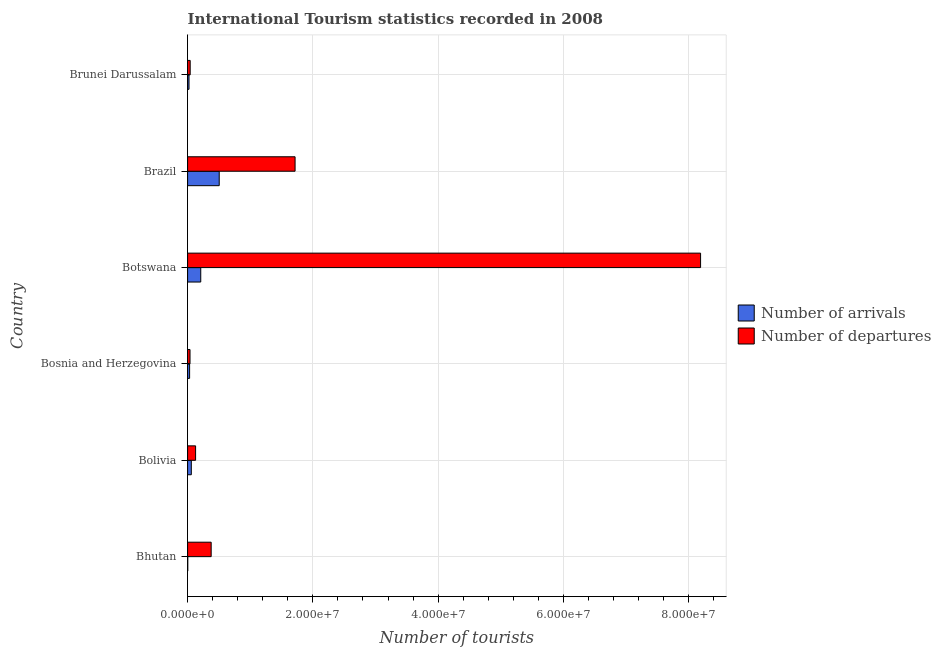How many different coloured bars are there?
Keep it short and to the point. 2. How many bars are there on the 6th tick from the top?
Give a very brief answer. 2. How many bars are there on the 6th tick from the bottom?
Offer a very short reply. 2. What is the label of the 5th group of bars from the top?
Your answer should be very brief. Bolivia. What is the number of tourist arrivals in Botswana?
Give a very brief answer. 2.10e+06. Across all countries, what is the maximum number of tourist arrivals?
Keep it short and to the point. 5.05e+06. Across all countries, what is the minimum number of tourist arrivals?
Your answer should be compact. 2.80e+04. In which country was the number of tourist arrivals minimum?
Your answer should be very brief. Bhutan. What is the total number of tourist arrivals in the graph?
Provide a short and direct response. 8.32e+06. What is the difference between the number of tourist departures in Botswana and that in Brazil?
Offer a terse response. 6.47e+07. What is the difference between the number of tourist arrivals in Botswana and the number of tourist departures in Bolivia?
Ensure brevity in your answer.  8.24e+05. What is the average number of tourist arrivals per country?
Ensure brevity in your answer.  1.39e+06. What is the difference between the number of tourist departures and number of tourist arrivals in Brunei Darussalam?
Provide a succinct answer. 1.88e+05. In how many countries, is the number of tourist departures greater than 28000000 ?
Give a very brief answer. 1. What is the ratio of the number of tourist departures in Botswana to that in Brazil?
Ensure brevity in your answer.  4.77. Is the number of tourist arrivals in Botswana less than that in Brunei Darussalam?
Your answer should be very brief. No. What is the difference between the highest and the second highest number of tourist arrivals?
Offer a terse response. 2.95e+06. What is the difference between the highest and the lowest number of tourist arrivals?
Offer a terse response. 5.02e+06. In how many countries, is the number of tourist arrivals greater than the average number of tourist arrivals taken over all countries?
Offer a very short reply. 2. Is the sum of the number of tourist departures in Bhutan and Botswana greater than the maximum number of tourist arrivals across all countries?
Your answer should be compact. Yes. What does the 2nd bar from the top in Brazil represents?
Make the answer very short. Number of arrivals. What does the 1st bar from the bottom in Botswana represents?
Your answer should be very brief. Number of arrivals. Are all the bars in the graph horizontal?
Keep it short and to the point. Yes. How many countries are there in the graph?
Keep it short and to the point. 6. What is the difference between two consecutive major ticks on the X-axis?
Provide a short and direct response. 2.00e+07. Are the values on the major ticks of X-axis written in scientific E-notation?
Give a very brief answer. Yes. Does the graph contain any zero values?
Your answer should be compact. No. How are the legend labels stacked?
Provide a short and direct response. Vertical. What is the title of the graph?
Offer a terse response. International Tourism statistics recorded in 2008. Does "Researchers" appear as one of the legend labels in the graph?
Your response must be concise. No. What is the label or title of the X-axis?
Your answer should be compact. Number of tourists. What is the label or title of the Y-axis?
Ensure brevity in your answer.  Country. What is the Number of tourists of Number of arrivals in Bhutan?
Give a very brief answer. 2.80e+04. What is the Number of tourists of Number of departures in Bhutan?
Give a very brief answer. 3.76e+06. What is the Number of tourists in Number of arrivals in Bolivia?
Ensure brevity in your answer.  5.94e+05. What is the Number of tourists of Number of departures in Bolivia?
Your answer should be very brief. 1.28e+06. What is the Number of tourists in Number of arrivals in Bosnia and Herzegovina?
Your answer should be very brief. 3.22e+05. What is the Number of tourists of Number of departures in Bosnia and Herzegovina?
Your answer should be compact. 3.87e+05. What is the Number of tourists of Number of arrivals in Botswana?
Offer a terse response. 2.10e+06. What is the Number of tourists of Number of departures in Botswana?
Your response must be concise. 8.19e+07. What is the Number of tourists in Number of arrivals in Brazil?
Offer a terse response. 5.05e+06. What is the Number of tourists in Number of departures in Brazil?
Your answer should be very brief. 1.72e+07. What is the Number of tourists of Number of arrivals in Brunei Darussalam?
Ensure brevity in your answer.  2.26e+05. What is the Number of tourists of Number of departures in Brunei Darussalam?
Give a very brief answer. 4.14e+05. Across all countries, what is the maximum Number of tourists in Number of arrivals?
Ensure brevity in your answer.  5.05e+06. Across all countries, what is the maximum Number of tourists of Number of departures?
Give a very brief answer. 8.19e+07. Across all countries, what is the minimum Number of tourists of Number of arrivals?
Offer a terse response. 2.80e+04. Across all countries, what is the minimum Number of tourists in Number of departures?
Provide a succinct answer. 3.87e+05. What is the total Number of tourists of Number of arrivals in the graph?
Keep it short and to the point. 8.32e+06. What is the total Number of tourists in Number of departures in the graph?
Offer a terse response. 1.05e+08. What is the difference between the Number of tourists of Number of arrivals in Bhutan and that in Bolivia?
Provide a succinct answer. -5.66e+05. What is the difference between the Number of tourists of Number of departures in Bhutan and that in Bolivia?
Make the answer very short. 2.49e+06. What is the difference between the Number of tourists in Number of arrivals in Bhutan and that in Bosnia and Herzegovina?
Ensure brevity in your answer.  -2.94e+05. What is the difference between the Number of tourists of Number of departures in Bhutan and that in Bosnia and Herzegovina?
Your answer should be compact. 3.38e+06. What is the difference between the Number of tourists in Number of arrivals in Bhutan and that in Botswana?
Offer a very short reply. -2.07e+06. What is the difference between the Number of tourists in Number of departures in Bhutan and that in Botswana?
Offer a terse response. -7.81e+07. What is the difference between the Number of tourists in Number of arrivals in Bhutan and that in Brazil?
Keep it short and to the point. -5.02e+06. What is the difference between the Number of tourists of Number of departures in Bhutan and that in Brazil?
Your answer should be compact. -1.34e+07. What is the difference between the Number of tourists of Number of arrivals in Bhutan and that in Brunei Darussalam?
Make the answer very short. -1.98e+05. What is the difference between the Number of tourists of Number of departures in Bhutan and that in Brunei Darussalam?
Give a very brief answer. 3.35e+06. What is the difference between the Number of tourists of Number of arrivals in Bolivia and that in Bosnia and Herzegovina?
Offer a terse response. 2.72e+05. What is the difference between the Number of tourists in Number of departures in Bolivia and that in Bosnia and Herzegovina?
Give a very brief answer. 8.90e+05. What is the difference between the Number of tourists in Number of arrivals in Bolivia and that in Botswana?
Your answer should be very brief. -1.51e+06. What is the difference between the Number of tourists in Number of departures in Bolivia and that in Botswana?
Your answer should be very brief. -8.06e+07. What is the difference between the Number of tourists of Number of arrivals in Bolivia and that in Brazil?
Ensure brevity in your answer.  -4.46e+06. What is the difference between the Number of tourists of Number of departures in Bolivia and that in Brazil?
Provide a succinct answer. -1.59e+07. What is the difference between the Number of tourists in Number of arrivals in Bolivia and that in Brunei Darussalam?
Your answer should be very brief. 3.68e+05. What is the difference between the Number of tourists in Number of departures in Bolivia and that in Brunei Darussalam?
Make the answer very short. 8.63e+05. What is the difference between the Number of tourists of Number of arrivals in Bosnia and Herzegovina and that in Botswana?
Give a very brief answer. -1.78e+06. What is the difference between the Number of tourists in Number of departures in Bosnia and Herzegovina and that in Botswana?
Your answer should be very brief. -8.15e+07. What is the difference between the Number of tourists of Number of arrivals in Bosnia and Herzegovina and that in Brazil?
Offer a very short reply. -4.73e+06. What is the difference between the Number of tourists of Number of departures in Bosnia and Herzegovina and that in Brazil?
Offer a terse response. -1.68e+07. What is the difference between the Number of tourists in Number of arrivals in Bosnia and Herzegovina and that in Brunei Darussalam?
Provide a succinct answer. 9.60e+04. What is the difference between the Number of tourists of Number of departures in Bosnia and Herzegovina and that in Brunei Darussalam?
Make the answer very short. -2.70e+04. What is the difference between the Number of tourists of Number of arrivals in Botswana and that in Brazil?
Give a very brief answer. -2.95e+06. What is the difference between the Number of tourists in Number of departures in Botswana and that in Brazil?
Ensure brevity in your answer.  6.47e+07. What is the difference between the Number of tourists in Number of arrivals in Botswana and that in Brunei Darussalam?
Your response must be concise. 1.88e+06. What is the difference between the Number of tourists in Number of departures in Botswana and that in Brunei Darussalam?
Provide a succinct answer. 8.15e+07. What is the difference between the Number of tourists of Number of arrivals in Brazil and that in Brunei Darussalam?
Your answer should be compact. 4.82e+06. What is the difference between the Number of tourists in Number of departures in Brazil and that in Brunei Darussalam?
Ensure brevity in your answer.  1.67e+07. What is the difference between the Number of tourists of Number of arrivals in Bhutan and the Number of tourists of Number of departures in Bolivia?
Your answer should be very brief. -1.25e+06. What is the difference between the Number of tourists in Number of arrivals in Bhutan and the Number of tourists in Number of departures in Bosnia and Herzegovina?
Offer a very short reply. -3.59e+05. What is the difference between the Number of tourists in Number of arrivals in Bhutan and the Number of tourists in Number of departures in Botswana?
Offer a very short reply. -8.19e+07. What is the difference between the Number of tourists in Number of arrivals in Bhutan and the Number of tourists in Number of departures in Brazil?
Give a very brief answer. -1.71e+07. What is the difference between the Number of tourists in Number of arrivals in Bhutan and the Number of tourists in Number of departures in Brunei Darussalam?
Your response must be concise. -3.86e+05. What is the difference between the Number of tourists in Number of arrivals in Bolivia and the Number of tourists in Number of departures in Bosnia and Herzegovina?
Ensure brevity in your answer.  2.07e+05. What is the difference between the Number of tourists of Number of arrivals in Bolivia and the Number of tourists of Number of departures in Botswana?
Provide a short and direct response. -8.13e+07. What is the difference between the Number of tourists of Number of arrivals in Bolivia and the Number of tourists of Number of departures in Brazil?
Ensure brevity in your answer.  -1.66e+07. What is the difference between the Number of tourists of Number of arrivals in Bosnia and Herzegovina and the Number of tourists of Number of departures in Botswana?
Give a very brief answer. -8.16e+07. What is the difference between the Number of tourists of Number of arrivals in Bosnia and Herzegovina and the Number of tourists of Number of departures in Brazil?
Your response must be concise. -1.68e+07. What is the difference between the Number of tourists in Number of arrivals in Bosnia and Herzegovina and the Number of tourists in Number of departures in Brunei Darussalam?
Make the answer very short. -9.20e+04. What is the difference between the Number of tourists in Number of arrivals in Botswana and the Number of tourists in Number of departures in Brazil?
Keep it short and to the point. -1.51e+07. What is the difference between the Number of tourists in Number of arrivals in Botswana and the Number of tourists in Number of departures in Brunei Darussalam?
Make the answer very short. 1.69e+06. What is the difference between the Number of tourists of Number of arrivals in Brazil and the Number of tourists of Number of departures in Brunei Darussalam?
Your answer should be very brief. 4.64e+06. What is the average Number of tourists of Number of arrivals per country?
Your response must be concise. 1.39e+06. What is the average Number of tourists of Number of departures per country?
Your answer should be compact. 1.75e+07. What is the difference between the Number of tourists of Number of arrivals and Number of tourists of Number of departures in Bhutan?
Provide a succinct answer. -3.74e+06. What is the difference between the Number of tourists of Number of arrivals and Number of tourists of Number of departures in Bolivia?
Your response must be concise. -6.83e+05. What is the difference between the Number of tourists in Number of arrivals and Number of tourists in Number of departures in Bosnia and Herzegovina?
Give a very brief answer. -6.50e+04. What is the difference between the Number of tourists in Number of arrivals and Number of tourists in Number of departures in Botswana?
Ensure brevity in your answer.  -7.98e+07. What is the difference between the Number of tourists of Number of arrivals and Number of tourists of Number of departures in Brazil?
Make the answer very short. -1.21e+07. What is the difference between the Number of tourists in Number of arrivals and Number of tourists in Number of departures in Brunei Darussalam?
Provide a short and direct response. -1.88e+05. What is the ratio of the Number of tourists in Number of arrivals in Bhutan to that in Bolivia?
Provide a short and direct response. 0.05. What is the ratio of the Number of tourists of Number of departures in Bhutan to that in Bolivia?
Provide a succinct answer. 2.95. What is the ratio of the Number of tourists of Number of arrivals in Bhutan to that in Bosnia and Herzegovina?
Keep it short and to the point. 0.09. What is the ratio of the Number of tourists in Number of departures in Bhutan to that in Bosnia and Herzegovina?
Your response must be concise. 9.73. What is the ratio of the Number of tourists in Number of arrivals in Bhutan to that in Botswana?
Your response must be concise. 0.01. What is the ratio of the Number of tourists of Number of departures in Bhutan to that in Botswana?
Your answer should be compact. 0.05. What is the ratio of the Number of tourists of Number of arrivals in Bhutan to that in Brazil?
Offer a very short reply. 0.01. What is the ratio of the Number of tourists of Number of departures in Bhutan to that in Brazil?
Your response must be concise. 0.22. What is the ratio of the Number of tourists of Number of arrivals in Bhutan to that in Brunei Darussalam?
Give a very brief answer. 0.12. What is the ratio of the Number of tourists in Number of departures in Bhutan to that in Brunei Darussalam?
Keep it short and to the point. 9.09. What is the ratio of the Number of tourists in Number of arrivals in Bolivia to that in Bosnia and Herzegovina?
Your answer should be compact. 1.84. What is the ratio of the Number of tourists in Number of departures in Bolivia to that in Bosnia and Herzegovina?
Give a very brief answer. 3.3. What is the ratio of the Number of tourists of Number of arrivals in Bolivia to that in Botswana?
Offer a very short reply. 0.28. What is the ratio of the Number of tourists in Number of departures in Bolivia to that in Botswana?
Provide a succinct answer. 0.02. What is the ratio of the Number of tourists of Number of arrivals in Bolivia to that in Brazil?
Provide a succinct answer. 0.12. What is the ratio of the Number of tourists of Number of departures in Bolivia to that in Brazil?
Provide a succinct answer. 0.07. What is the ratio of the Number of tourists in Number of arrivals in Bolivia to that in Brunei Darussalam?
Make the answer very short. 2.63. What is the ratio of the Number of tourists of Number of departures in Bolivia to that in Brunei Darussalam?
Ensure brevity in your answer.  3.08. What is the ratio of the Number of tourists in Number of arrivals in Bosnia and Herzegovina to that in Botswana?
Your answer should be compact. 0.15. What is the ratio of the Number of tourists in Number of departures in Bosnia and Herzegovina to that in Botswana?
Offer a terse response. 0. What is the ratio of the Number of tourists of Number of arrivals in Bosnia and Herzegovina to that in Brazil?
Ensure brevity in your answer.  0.06. What is the ratio of the Number of tourists of Number of departures in Bosnia and Herzegovina to that in Brazil?
Provide a succinct answer. 0.02. What is the ratio of the Number of tourists in Number of arrivals in Bosnia and Herzegovina to that in Brunei Darussalam?
Your answer should be very brief. 1.42. What is the ratio of the Number of tourists in Number of departures in Bosnia and Herzegovina to that in Brunei Darussalam?
Keep it short and to the point. 0.93. What is the ratio of the Number of tourists of Number of arrivals in Botswana to that in Brazil?
Provide a succinct answer. 0.42. What is the ratio of the Number of tourists of Number of departures in Botswana to that in Brazil?
Your answer should be very brief. 4.77. What is the ratio of the Number of tourists of Number of arrivals in Botswana to that in Brunei Darussalam?
Your response must be concise. 9.3. What is the ratio of the Number of tourists of Number of departures in Botswana to that in Brunei Darussalam?
Keep it short and to the point. 197.85. What is the ratio of the Number of tourists in Number of arrivals in Brazil to that in Brunei Darussalam?
Ensure brevity in your answer.  22.35. What is the ratio of the Number of tourists in Number of departures in Brazil to that in Brunei Darussalam?
Provide a short and direct response. 41.45. What is the difference between the highest and the second highest Number of tourists in Number of arrivals?
Your answer should be compact. 2.95e+06. What is the difference between the highest and the second highest Number of tourists in Number of departures?
Your answer should be compact. 6.47e+07. What is the difference between the highest and the lowest Number of tourists in Number of arrivals?
Provide a short and direct response. 5.02e+06. What is the difference between the highest and the lowest Number of tourists of Number of departures?
Offer a very short reply. 8.15e+07. 